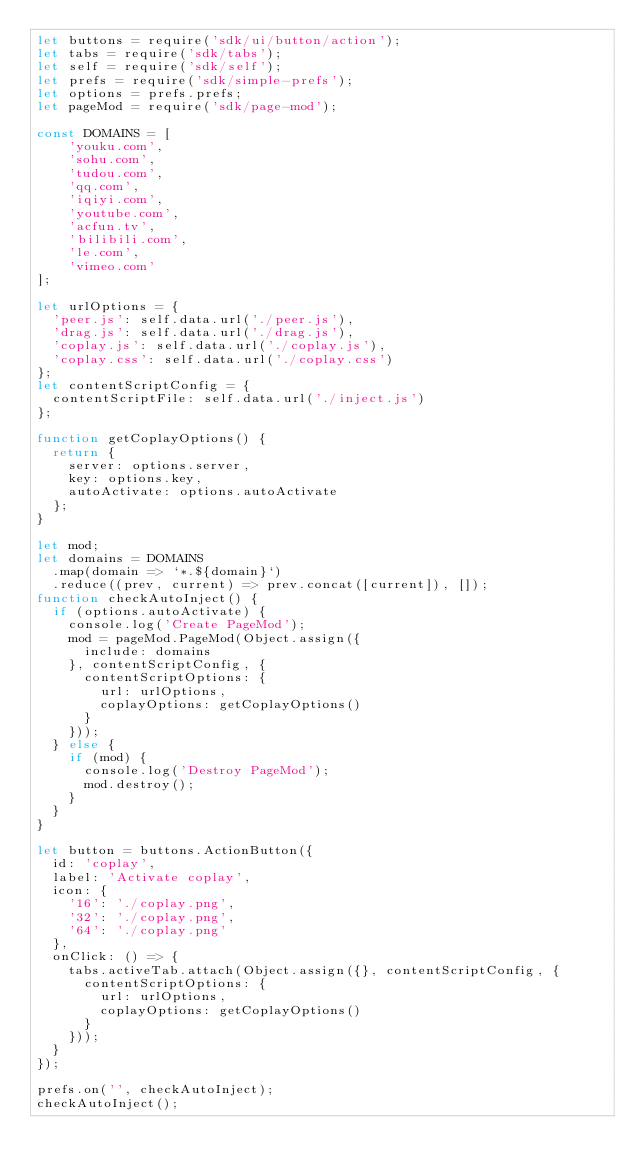Convert code to text. <code><loc_0><loc_0><loc_500><loc_500><_JavaScript_>let buttons = require('sdk/ui/button/action');
let tabs = require('sdk/tabs');
let self = require('sdk/self');
let prefs = require('sdk/simple-prefs');
let options = prefs.prefs;
let pageMod = require('sdk/page-mod');

const DOMAINS = [
    'youku.com',
    'sohu.com',
    'tudou.com',
    'qq.com',
    'iqiyi.com',
    'youtube.com',
    'acfun.tv',
    'bilibili.com',
    'le.com',
    'vimeo.com'
];

let urlOptions = {
  'peer.js': self.data.url('./peer.js'),
  'drag.js': self.data.url('./drag.js'),
  'coplay.js': self.data.url('./coplay.js'),
  'coplay.css': self.data.url('./coplay.css')
};
let contentScriptConfig = {
  contentScriptFile: self.data.url('./inject.js')
};

function getCoplayOptions() {
  return {
    server: options.server,
    key: options.key,
    autoActivate: options.autoActivate
  };
}

let mod;
let domains = DOMAINS
  .map(domain => `*.${domain}`)
  .reduce((prev, current) => prev.concat([current]), []);
function checkAutoInject() {
  if (options.autoActivate) {
    console.log('Create PageMod');
    mod = pageMod.PageMod(Object.assign({
      include: domains
    }, contentScriptConfig, {
      contentScriptOptions: {
        url: urlOptions,
        coplayOptions: getCoplayOptions()
      }
    }));
  } else {
    if (mod) {
      console.log('Destroy PageMod');
      mod.destroy();
    }
  }
}

let button = buttons.ActionButton({
  id: 'coplay',
  label: 'Activate coplay',
  icon: {
    '16': './coplay.png',
    '32': './coplay.png',
    '64': './coplay.png'
  },
  onClick: () => {
    tabs.activeTab.attach(Object.assign({}, contentScriptConfig, {
      contentScriptOptions: {
        url: urlOptions,
        coplayOptions: getCoplayOptions()
      }
    }));
  }
});

prefs.on('', checkAutoInject);
checkAutoInject();
</code> 